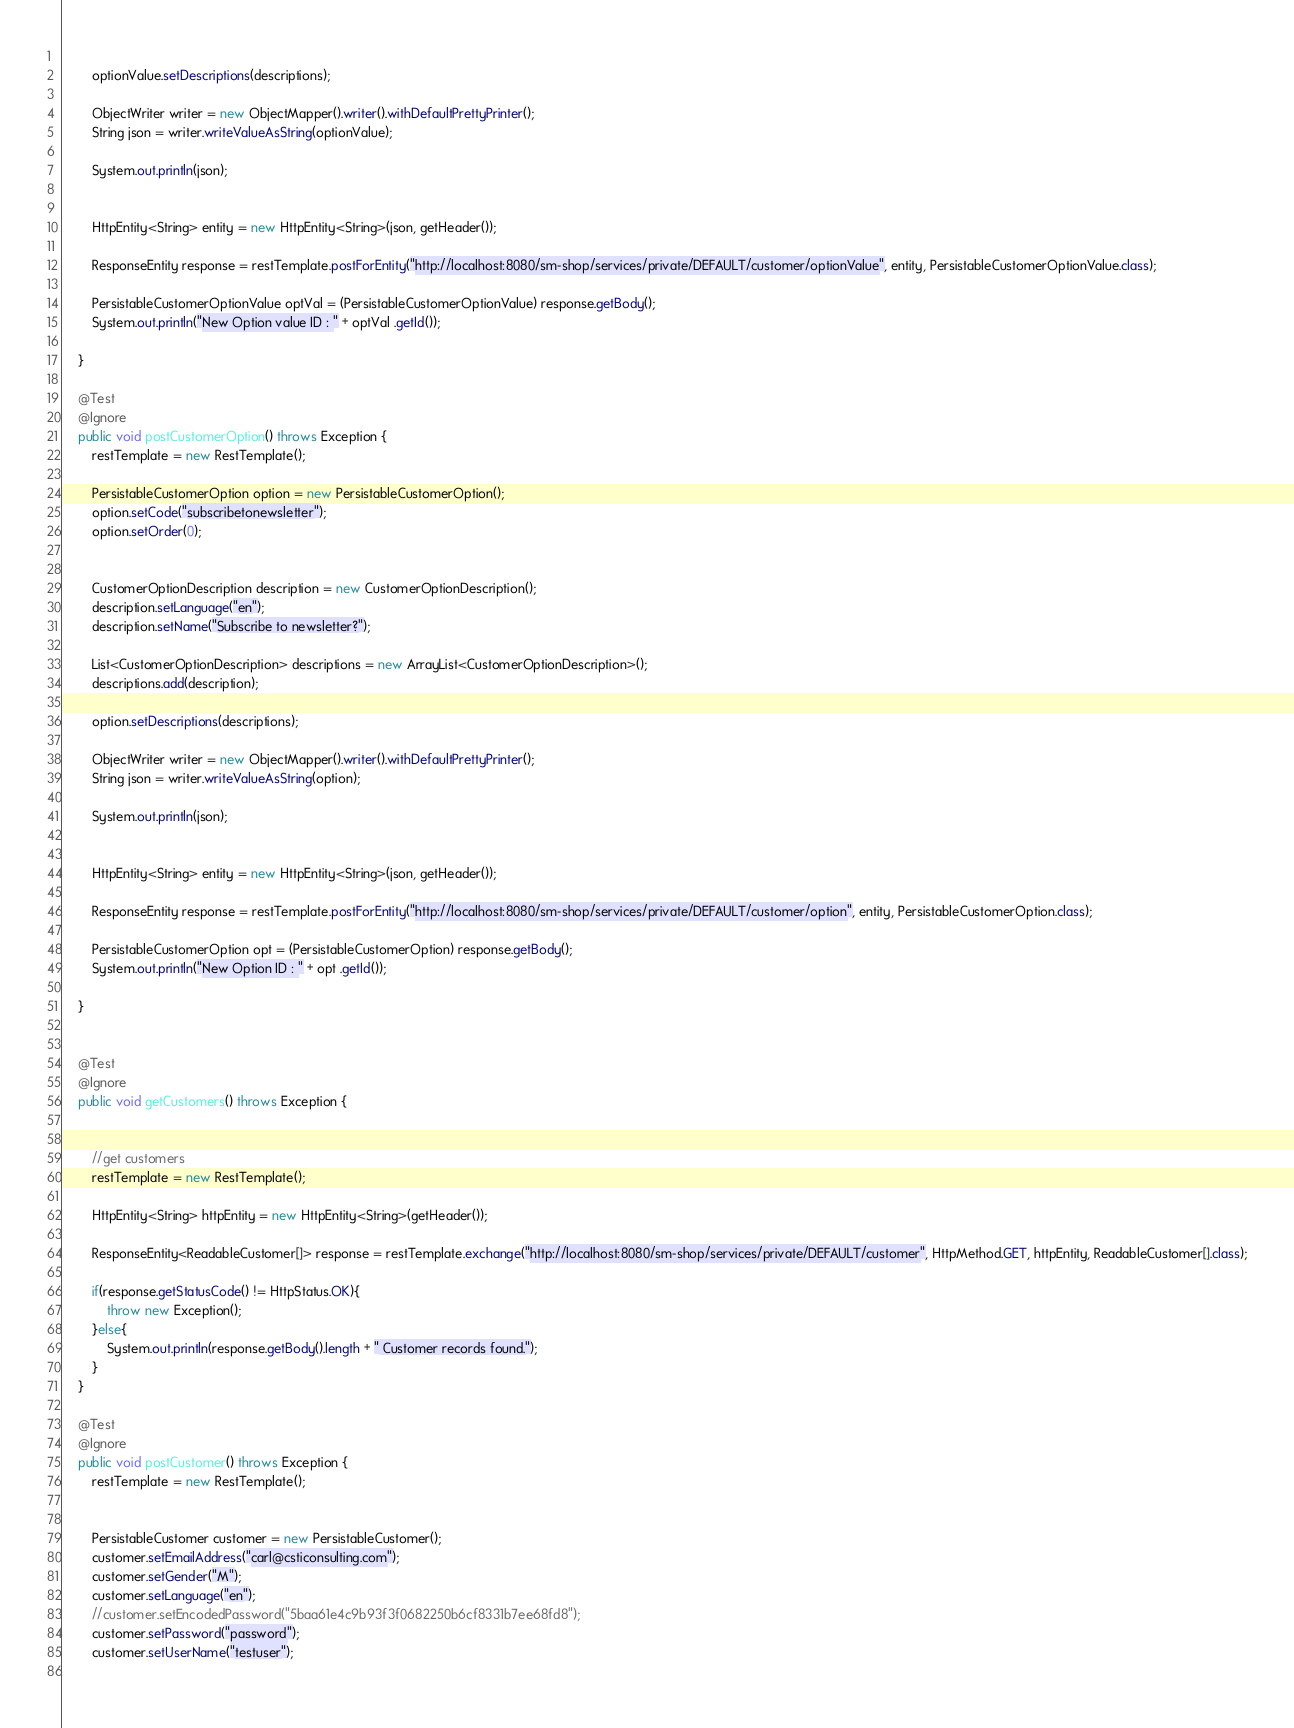Convert code to text. <code><loc_0><loc_0><loc_500><loc_500><_Java_>		
		optionValue.setDescriptions(descriptions);
		
		ObjectWriter writer = new ObjectMapper().writer().withDefaultPrettyPrinter();
		String json = writer.writeValueAsString(optionValue);
		
		System.out.println(json);
		

		HttpEntity<String> entity = new HttpEntity<String>(json, getHeader());

		ResponseEntity response = restTemplate.postForEntity("http://localhost:8080/sm-shop/services/private/DEFAULT/customer/optionValue", entity, PersistableCustomerOptionValue.class);

		PersistableCustomerOptionValue optVal = (PersistableCustomerOptionValue) response.getBody();
		System.out.println("New Option value ID : " + optVal .getId());

	}
	
	@Test
	@Ignore
	public void postCustomerOption() throws Exception {
		restTemplate = new RestTemplate();

		PersistableCustomerOption option = new PersistableCustomerOption();
		option.setCode("subscribetonewsletter");
		option.setOrder(0);

		
		CustomerOptionDescription description = new CustomerOptionDescription();
		description.setLanguage("en");
		description.setName("Subscribe to newsletter?");
		
		List<CustomerOptionDescription> descriptions = new ArrayList<CustomerOptionDescription>();
		descriptions.add(description);
		
		option.setDescriptions(descriptions);
		
		ObjectWriter writer = new ObjectMapper().writer().withDefaultPrettyPrinter();
		String json = writer.writeValueAsString(option);
		
		System.out.println(json);
		

		HttpEntity<String> entity = new HttpEntity<String>(json, getHeader());

		ResponseEntity response = restTemplate.postForEntity("http://localhost:8080/sm-shop/services/private/DEFAULT/customer/option", entity, PersistableCustomerOption.class);

		PersistableCustomerOption opt = (PersistableCustomerOption) response.getBody();
		System.out.println("New Option ID : " + opt .getId());

	}
	

	@Test
	@Ignore
	public void getCustomers() throws Exception {
		
		
		//get customers
		restTemplate = new RestTemplate();
		
		HttpEntity<String> httpEntity = new HttpEntity<String>(getHeader());
		
		ResponseEntity<ReadableCustomer[]> response = restTemplate.exchange("http://localhost:8080/sm-shop/services/private/DEFAULT/customer", HttpMethod.GET, httpEntity, ReadableCustomer[].class);
		
		if(response.getStatusCode() != HttpStatus.OK){
			throw new Exception();
		}else{
			System.out.println(response.getBody().length + " Customer records found.");
		}
	}

	@Test
	@Ignore
	public void postCustomer() throws Exception {
		restTemplate = new RestTemplate();
		
		
		PersistableCustomer customer = new PersistableCustomer();
		customer.setEmailAddress("carl@csticonsulting.com");
		customer.setGender("M");
		customer.setLanguage("en");
		//customer.setEncodedPassword("5baa61e4c9b93f3f0682250b6cf8331b7ee68fd8");
		customer.setPassword("password");
		customer.setUserName("testuser");
		</code> 